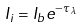Convert formula to latex. <formula><loc_0><loc_0><loc_500><loc_500>I _ { i } = I _ { b } e ^ { - \tau _ { \lambda } }</formula> 